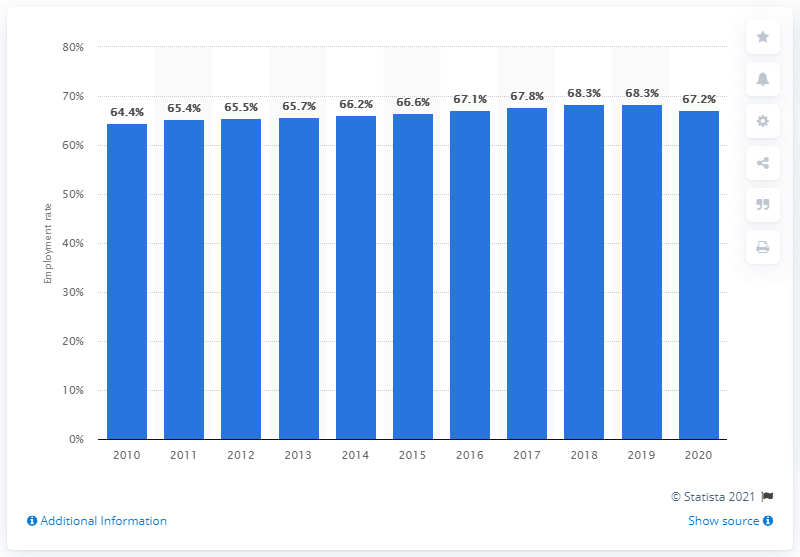Highlight a few significant elements in this photo. In 2020, the employment rate in Sweden was 67.2%. In 2010, Sweden's employment rate was 64.4%, which was the country's lowest employment rate at that time. 